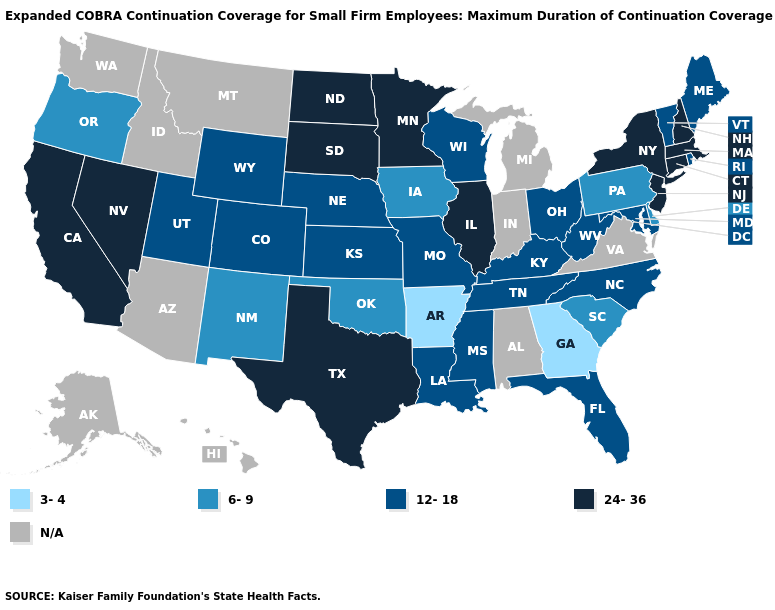Does Massachusetts have the highest value in the USA?
Concise answer only. Yes. Name the states that have a value in the range N/A?
Give a very brief answer. Alabama, Alaska, Arizona, Hawaii, Idaho, Indiana, Michigan, Montana, Virginia, Washington. What is the lowest value in the West?
Concise answer only. 6-9. Does Arkansas have the highest value in the USA?
Short answer required. No. Name the states that have a value in the range N/A?
Answer briefly. Alabama, Alaska, Arizona, Hawaii, Idaho, Indiana, Michigan, Montana, Virginia, Washington. Does Arkansas have the highest value in the USA?
Keep it brief. No. Which states hav the highest value in the South?
Be succinct. Texas. What is the lowest value in states that border Indiana?
Write a very short answer. 12-18. What is the value of West Virginia?
Write a very short answer. 12-18. Name the states that have a value in the range N/A?
Quick response, please. Alabama, Alaska, Arizona, Hawaii, Idaho, Indiana, Michigan, Montana, Virginia, Washington. What is the value of California?
Quick response, please. 24-36. Does New York have the highest value in the USA?
Give a very brief answer. Yes. Name the states that have a value in the range 6-9?
Write a very short answer. Delaware, Iowa, New Mexico, Oklahoma, Oregon, Pennsylvania, South Carolina. 